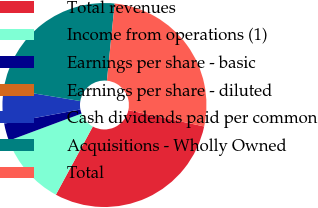<chart> <loc_0><loc_0><loc_500><loc_500><pie_chart><fcel>Total revenues<fcel>Income from operations (1)<fcel>Earnings per share - basic<fcel>Earnings per share - diluted<fcel>Cash dividends paid per common<fcel>Acquisitions - Wholly Owned<fcel>Total<nl><fcel>29.53%<fcel>11.42%<fcel>2.76%<fcel>0.0%<fcel>5.51%<fcel>24.01%<fcel>26.77%<nl></chart> 